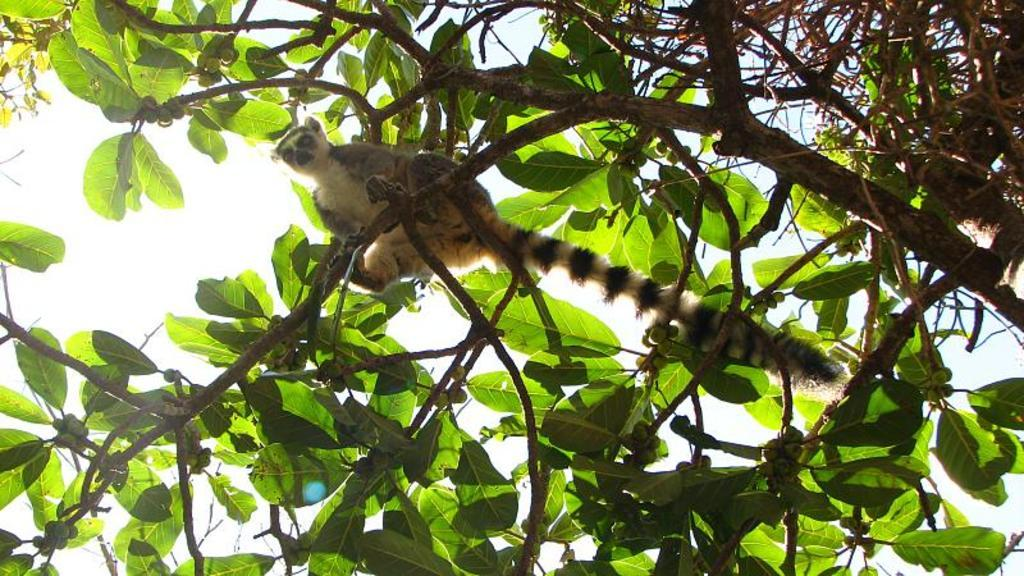What is sitting on the tree in the image? There is an animal sitting on the tree in the image. What else can be seen on the tree besides the animal? There are fruits on the tree. What is visible at the top of the image? The sky is visible at the top of the image. What message of good-bye is the farmer sending to the animal in the image? There is no farmer present in the image, and therefore no message of good-bye can be observed. How much wealth is associated with the fruits on the tree in the image? The image does not provide any information about the value or wealth associated with the fruits on the tree. 